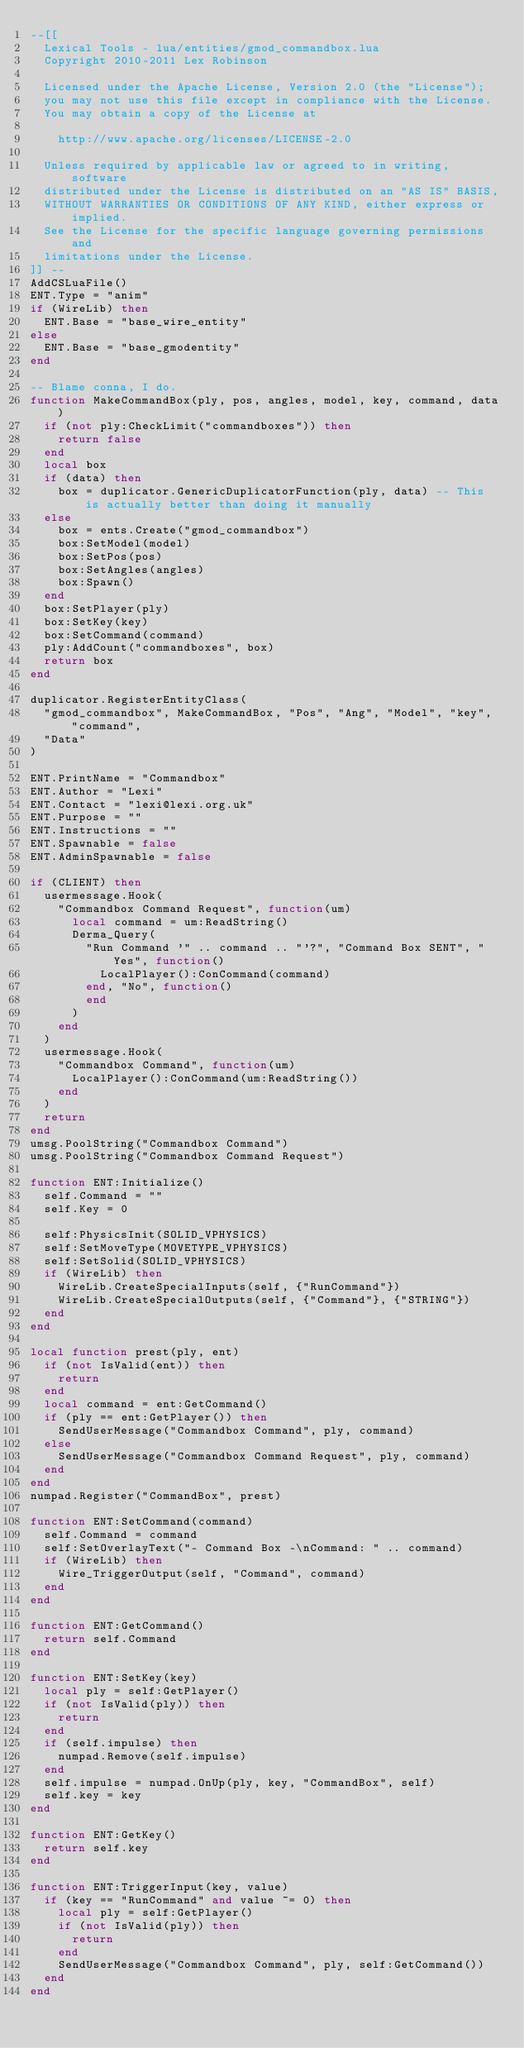<code> <loc_0><loc_0><loc_500><loc_500><_Lua_>--[[
	Lexical Tools - lua/entities/gmod_commandbox.lua
	Copyright 2010-2011 Lex Robinson

	Licensed under the Apache License, Version 2.0 (the "License");
	you may not use this file except in compliance with the License.
	You may obtain a copy of the License at

		http://www.apache.org/licenses/LICENSE-2.0

	Unless required by applicable law or agreed to in writing, software
	distributed under the License is distributed on an "AS IS" BASIS,
	WITHOUT WARRANTIES OR CONDITIONS OF ANY KIND, either express or implied.
	See the License for the specific language governing permissions and
	limitations under the License.
]] --
AddCSLuaFile()
ENT.Type = "anim"
if (WireLib) then
	ENT.Base = "base_wire_entity"
else
	ENT.Base = "base_gmodentity"
end

-- Blame conna, I do.
function MakeCommandBox(ply, pos, angles, model, key, command, data)
	if (not ply:CheckLimit("commandboxes")) then
		return false
	end
	local box
	if (data) then
		box = duplicator.GenericDuplicatorFunction(ply, data) -- This is actually better than doing it manually
	else
		box = ents.Create("gmod_commandbox")
		box:SetModel(model)
		box:SetPos(pos)
		box:SetAngles(angles)
		box:Spawn()
	end
	box:SetPlayer(ply)
	box:SetKey(key)
	box:SetCommand(command)
	ply:AddCount("commandboxes", box)
	return box
end

duplicator.RegisterEntityClass(
	"gmod_commandbox", MakeCommandBox, "Pos", "Ang", "Model", "key", "command",
	"Data"
)

ENT.PrintName = "Commandbox"
ENT.Author = "Lexi"
ENT.Contact = "lexi@lexi.org.uk"
ENT.Purpose = ""
ENT.Instructions = ""
ENT.Spawnable = false
ENT.AdminSpawnable = false

if (CLIENT) then
	usermessage.Hook(
		"Commandbox Command Request", function(um)
			local command = um:ReadString()
			Derma_Query(
				"Run Command '" .. command .. "'?", "Command Box SENT", "Yes", function()
					LocalPlayer():ConCommand(command)
				end, "No", function()
				end
			)
		end
	)
	usermessage.Hook(
		"Commandbox Command", function(um)
			LocalPlayer():ConCommand(um:ReadString())
		end
	)
	return
end
umsg.PoolString("Commandbox Command")
umsg.PoolString("Commandbox Command Request")

function ENT:Initialize()
	self.Command = ""
	self.Key = 0

	self:PhysicsInit(SOLID_VPHYSICS)
	self:SetMoveType(MOVETYPE_VPHYSICS)
	self:SetSolid(SOLID_VPHYSICS)
	if (WireLib) then
		WireLib.CreateSpecialInputs(self, {"RunCommand"})
		WireLib.CreateSpecialOutputs(self, {"Command"}, {"STRING"})
	end
end

local function prest(ply, ent)
	if (not IsValid(ent)) then
		return
	end
	local command = ent:GetCommand()
	if (ply == ent:GetPlayer()) then
		SendUserMessage("Commandbox Command", ply, command)
	else
		SendUserMessage("Commandbox Command Request", ply, command)
	end
end
numpad.Register("CommandBox", prest)

function ENT:SetCommand(command)
	self.Command = command
	self:SetOverlayText("- Command Box -\nCommand: " .. command)
	if (WireLib) then
		Wire_TriggerOutput(self, "Command", command)
	end
end

function ENT:GetCommand()
	return self.Command
end

function ENT:SetKey(key)
	local ply = self:GetPlayer()
	if (not IsValid(ply)) then
		return
	end
	if (self.impulse) then
		numpad.Remove(self.impulse)
	end
	self.impulse = numpad.OnUp(ply, key, "CommandBox", self)
	self.key = key
end

function ENT:GetKey()
	return self.key
end

function ENT:TriggerInput(key, value)
	if (key == "RunCommand" and value ~= 0) then
		local ply = self:GetPlayer()
		if (not IsValid(ply)) then
			return
		end
		SendUserMessage("Commandbox Command", ply, self:GetCommand())
	end
end
</code> 